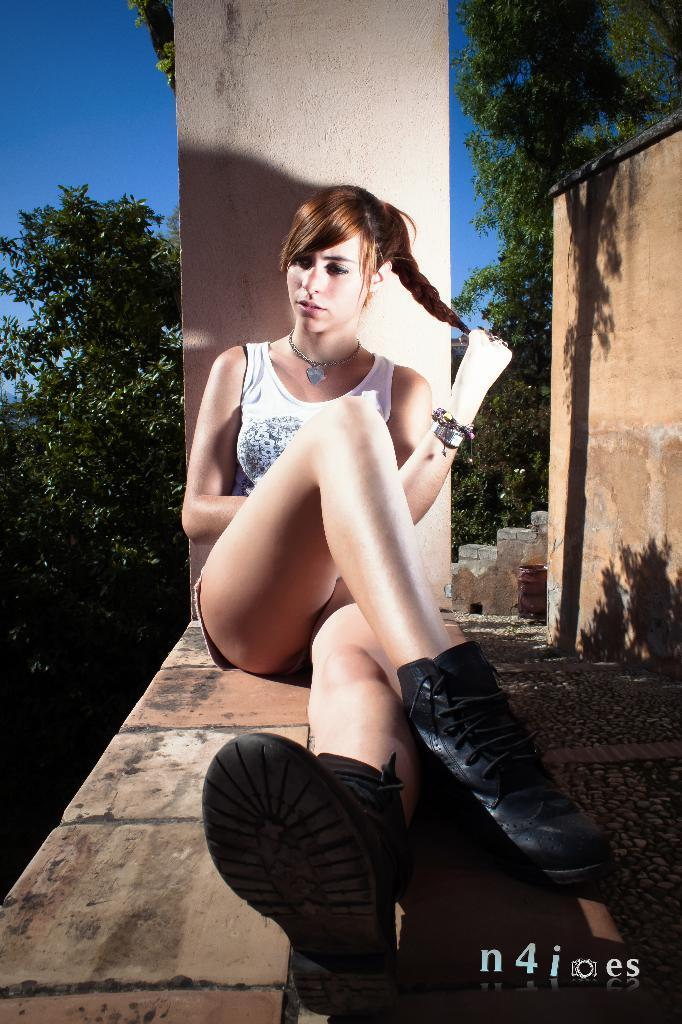What is the main subject in the image? There is a girl sitting in the image. What can be seen on the right side of the image? There is a wall on the right side of the image. What type of vegetation is present in the image? There are trees in the image. What is the color of the sky in the image? The sky is blue in the image. Where is the store located in the image? There is no store present in the image. How many kittens can be seen begging for food in the image? There are no kittens or begging activity present in the image. 